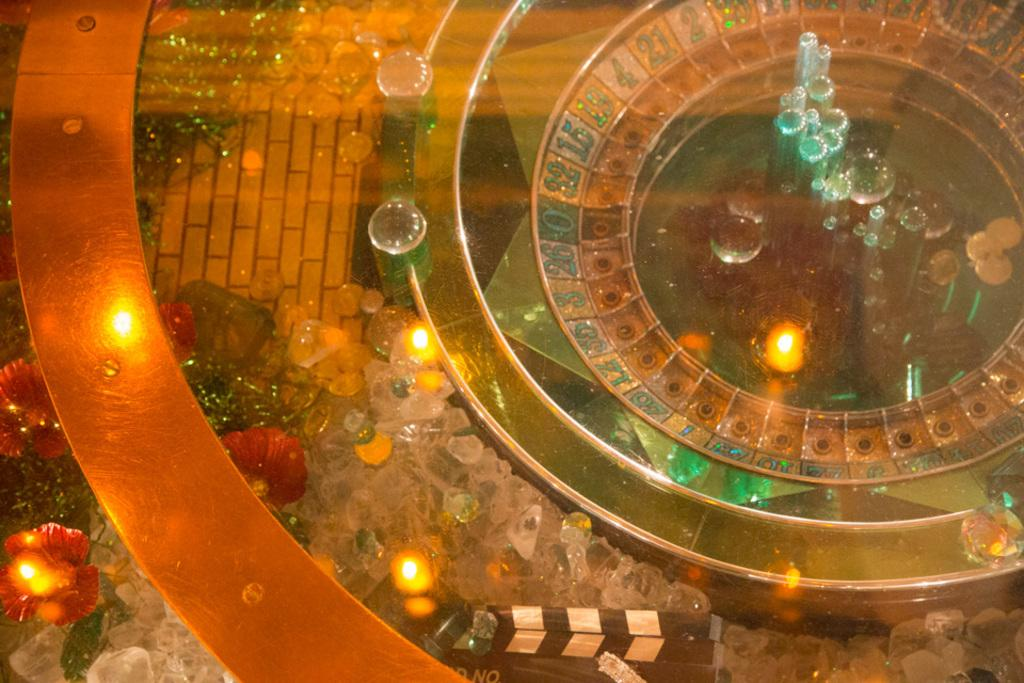What type of object is visible in the image? There is a glass object in the image. What type of furniture is visible in the image? There is no furniture present in the image; it only features a glass object. What type of vegetable is visible in the image? There is no vegetable present in the image; it only features a glass object. 